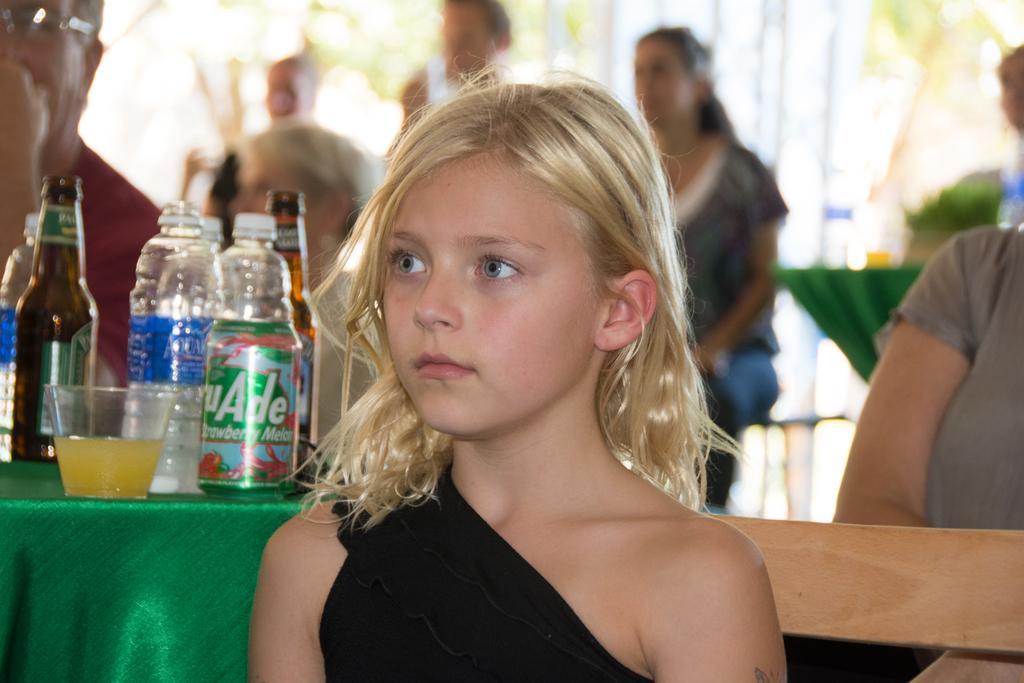How would you summarize this image in a sentence or two? In this image I can see few bottles and few objects on the green color cloth. I can see few people and the blurred background. 